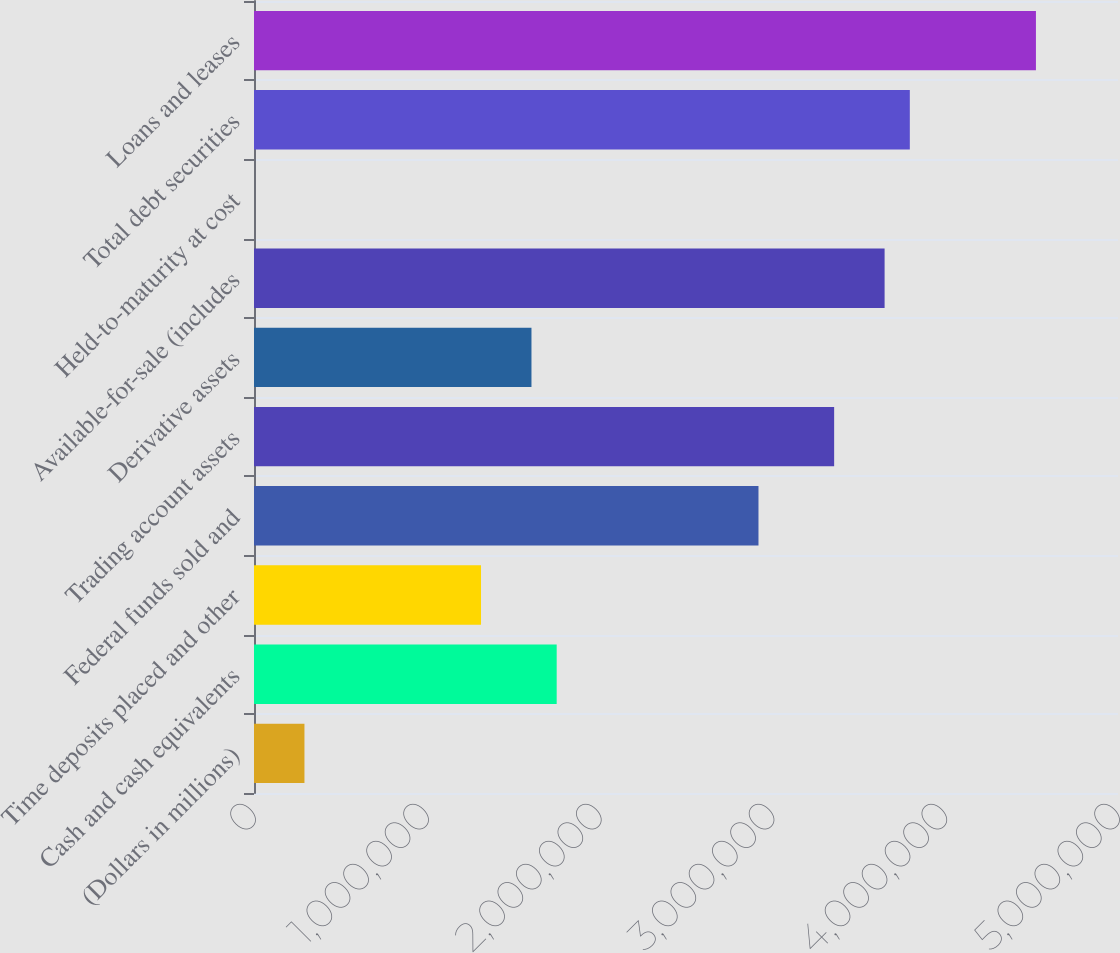<chart> <loc_0><loc_0><loc_500><loc_500><bar_chart><fcel>(Dollars in millions)<fcel>Cash and cash equivalents<fcel>Time deposits placed and other<fcel>Federal funds sold and<fcel>Trading account assets<fcel>Derivative assets<fcel>Available-for-sale (includes<fcel>Held-to-maturity at cost<fcel>Total debt securities<fcel>Loans and leases<nl><fcel>291979<fcel>1.75168e+06<fcel>1.31377e+06<fcel>2.91943e+06<fcel>3.35734e+06<fcel>1.60571e+06<fcel>3.64928e+06<fcel>40<fcel>3.79525e+06<fcel>4.5251e+06<nl></chart> 